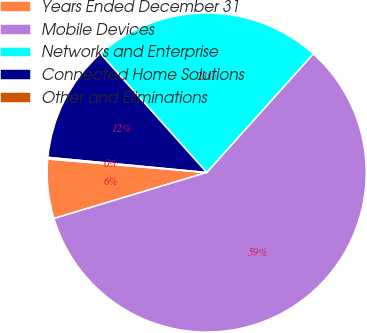Convert chart to OTSL. <chart><loc_0><loc_0><loc_500><loc_500><pie_chart><fcel>Years Ended December 31<fcel>Mobile Devices<fcel>Networks and Enterprise<fcel>Connected Home Solutions<fcel>Other and Eliminations<nl><fcel>6.01%<fcel>58.71%<fcel>23.26%<fcel>11.87%<fcel>0.16%<nl></chart> 